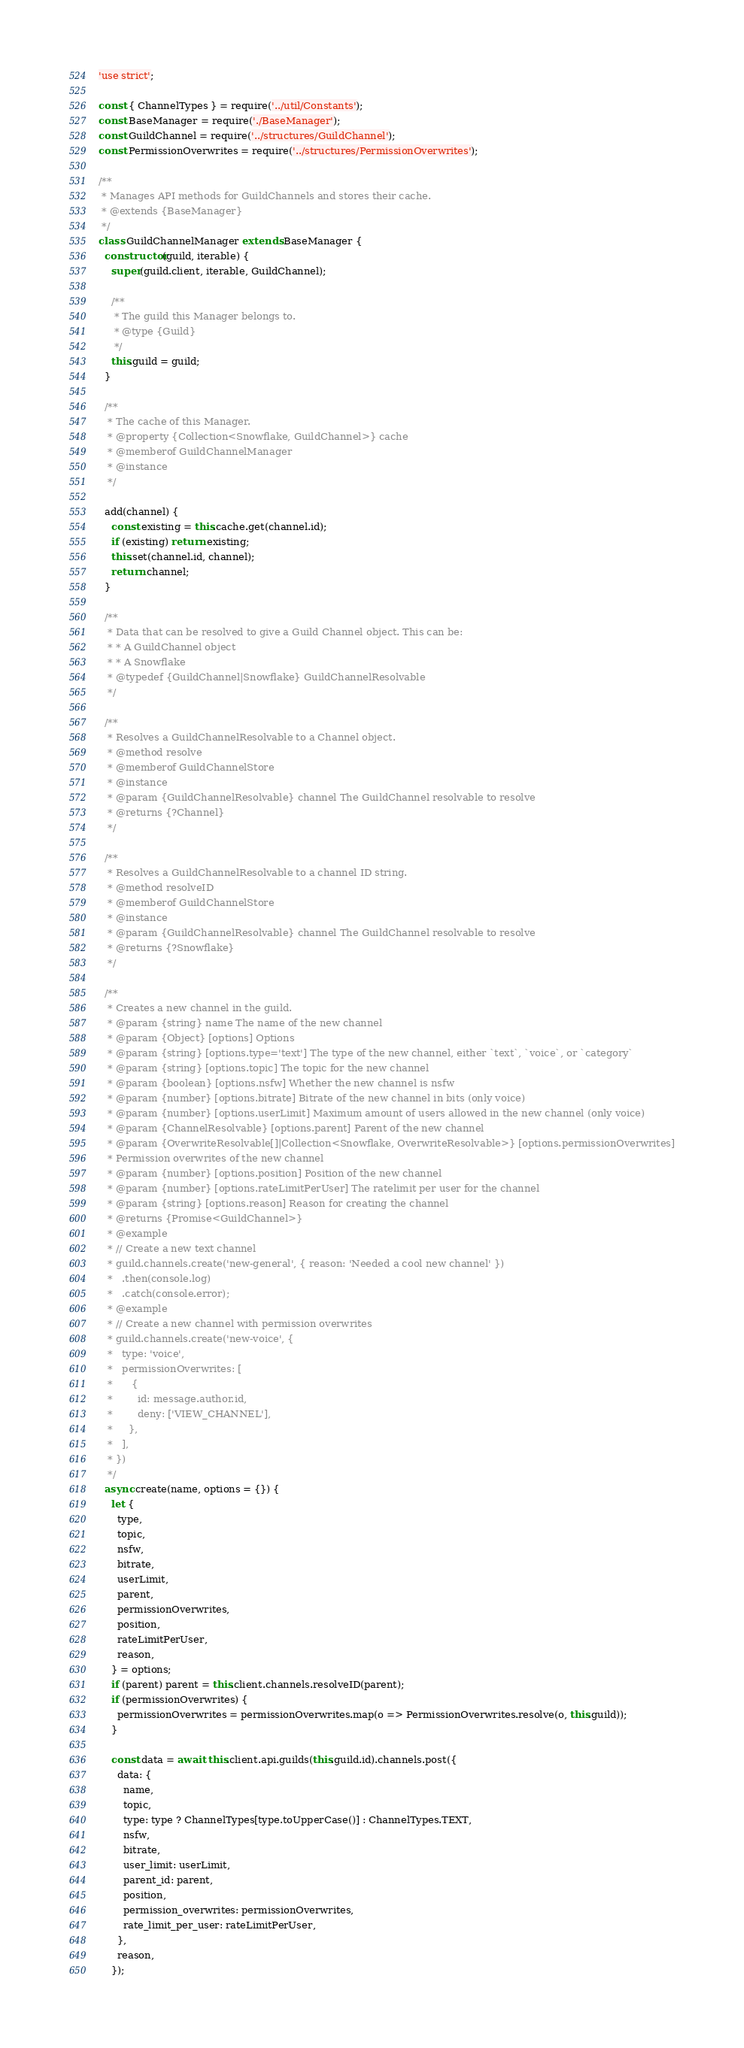Convert code to text. <code><loc_0><loc_0><loc_500><loc_500><_JavaScript_>'use strict';

const { ChannelTypes } = require('../util/Constants');
const BaseManager = require('./BaseManager');
const GuildChannel = require('../structures/GuildChannel');
const PermissionOverwrites = require('../structures/PermissionOverwrites');

/**
 * Manages API methods for GuildChannels and stores their cache.
 * @extends {BaseManager}
 */
class GuildChannelManager extends BaseManager {
  constructor(guild, iterable) {
    super(guild.client, iterable, GuildChannel);

    /**
     * The guild this Manager belongs to.
     * @type {Guild}
     */
    this.guild = guild;
  }

  /**
   * The cache of this Manager.
   * @property {Collection<Snowflake, GuildChannel>} cache
   * @memberof GuildChannelManager
   * @instance
   */

  add(channel) {
    const existing = this.cache.get(channel.id);
    if (existing) return existing;
    this.set(channel.id, channel);
    return channel;
  }

  /**
   * Data that can be resolved to give a Guild Channel object. This can be:
   * * A GuildChannel object
   * * A Snowflake
   * @typedef {GuildChannel|Snowflake} GuildChannelResolvable
   */

  /**
   * Resolves a GuildChannelResolvable to a Channel object.
   * @method resolve
   * @memberof GuildChannelStore
   * @instance
   * @param {GuildChannelResolvable} channel The GuildChannel resolvable to resolve
   * @returns {?Channel}
   */

  /**
   * Resolves a GuildChannelResolvable to a channel ID string.
   * @method resolveID
   * @memberof GuildChannelStore
   * @instance
   * @param {GuildChannelResolvable} channel The GuildChannel resolvable to resolve
   * @returns {?Snowflake}
   */

  /**
   * Creates a new channel in the guild.
   * @param {string} name The name of the new channel
   * @param {Object} [options] Options
   * @param {string} [options.type='text'] The type of the new channel, either `text`, `voice`, or `category`
   * @param {string} [options.topic] The topic for the new channel
   * @param {boolean} [options.nsfw] Whether the new channel is nsfw
   * @param {number} [options.bitrate] Bitrate of the new channel in bits (only voice)
   * @param {number} [options.userLimit] Maximum amount of users allowed in the new channel (only voice)
   * @param {ChannelResolvable} [options.parent] Parent of the new channel
   * @param {OverwriteResolvable[]|Collection<Snowflake, OverwriteResolvable>} [options.permissionOverwrites]
   * Permission overwrites of the new channel
   * @param {number} [options.position] Position of the new channel
   * @param {number} [options.rateLimitPerUser] The ratelimit per user for the channel
   * @param {string} [options.reason] Reason for creating the channel
   * @returns {Promise<GuildChannel>}
   * @example
   * // Create a new text channel
   * guild.channels.create('new-general', { reason: 'Needed a cool new channel' })
   *   .then(console.log)
   *   .catch(console.error);
   * @example
   * // Create a new channel with permission overwrites
   * guild.channels.create('new-voice', {
   *   type: 'voice',
   *   permissionOverwrites: [
   *      {
   *        id: message.author.id,
   *        deny: ['VIEW_CHANNEL'],
   *     },
   *   ],
   * })
   */
  async create(name, options = {}) {
    let {
      type,
      topic,
      nsfw,
      bitrate,
      userLimit,
      parent,
      permissionOverwrites,
      position,
      rateLimitPerUser,
      reason,
    } = options;
    if (parent) parent = this.client.channels.resolveID(parent);
    if (permissionOverwrites) {
      permissionOverwrites = permissionOverwrites.map(o => PermissionOverwrites.resolve(o, this.guild));
    }

    const data = await this.client.api.guilds(this.guild.id).channels.post({
      data: {
        name,
        topic,
        type: type ? ChannelTypes[type.toUpperCase()] : ChannelTypes.TEXT,
        nsfw,
        bitrate,
        user_limit: userLimit,
        parent_id: parent,
        position,
        permission_overwrites: permissionOverwrites,
        rate_limit_per_user: rateLimitPerUser,
      },
      reason,
    });</code> 